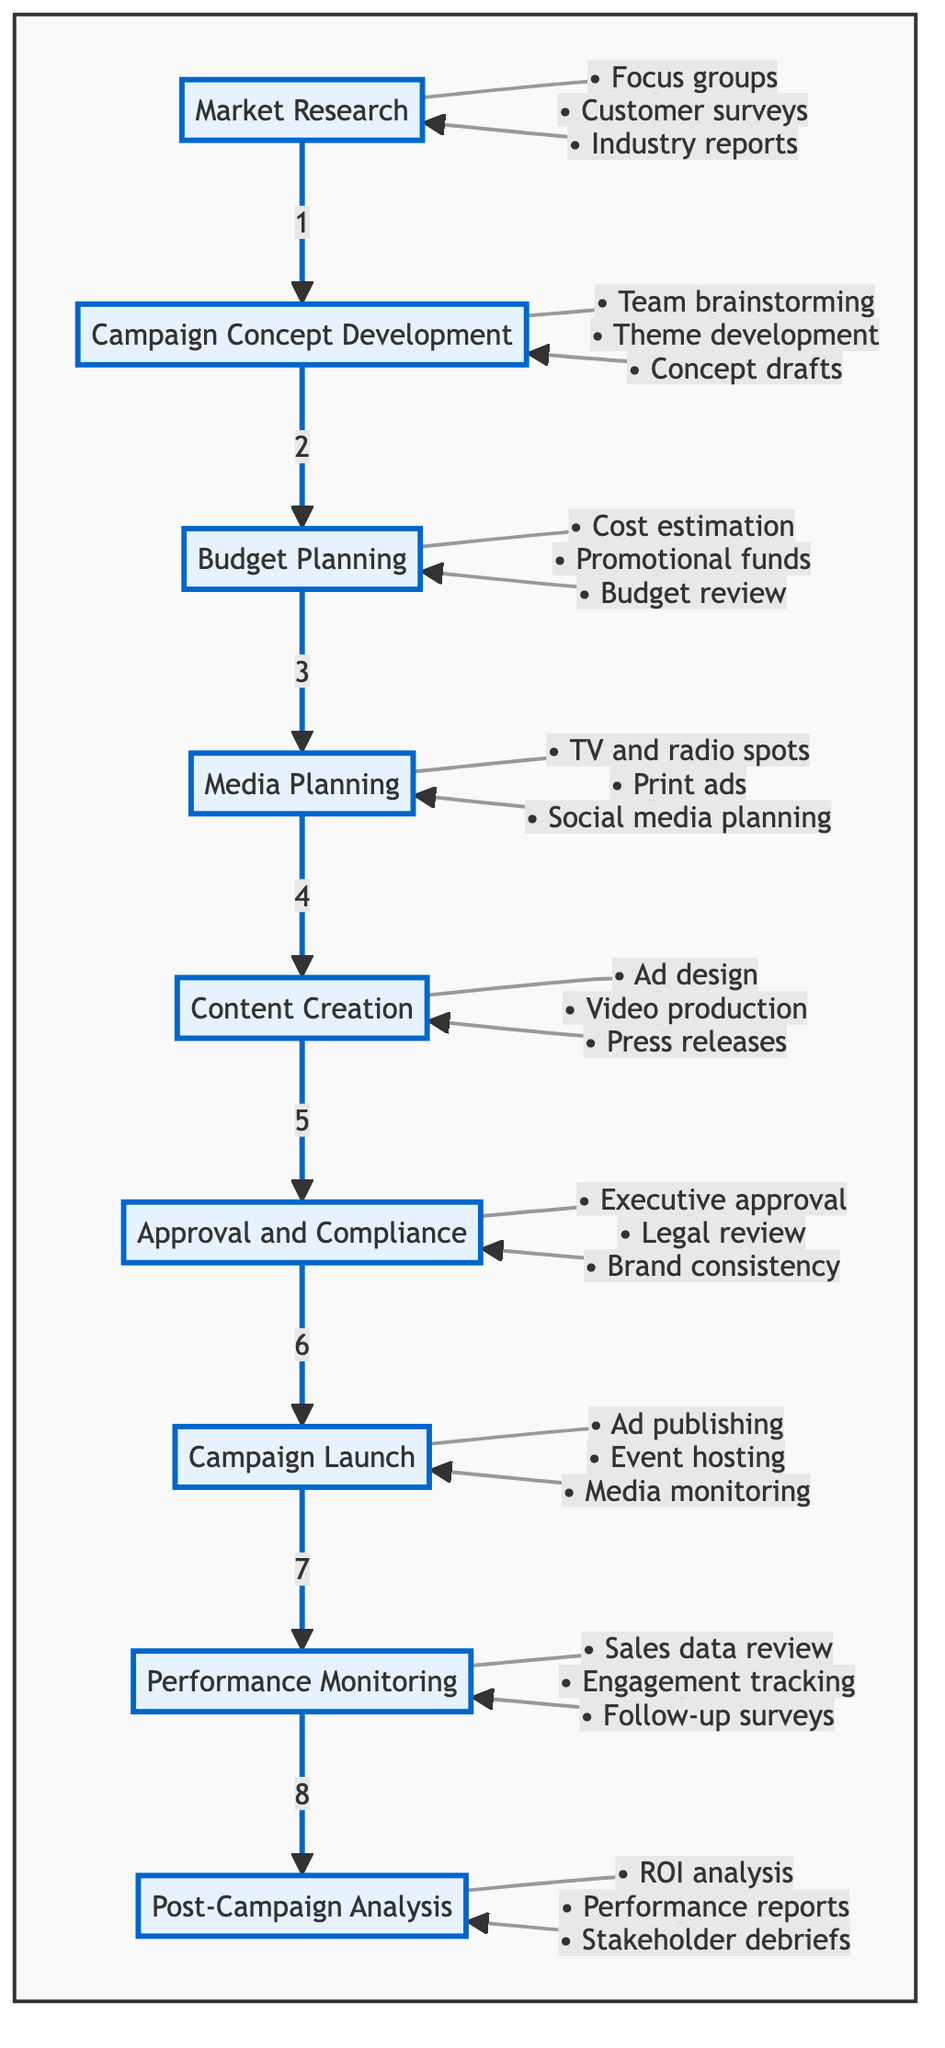What is the first stage of the campaign planning process? The diagram shows that the first stage is "Market Research", which is the initial step in the flowchart.
Answer: Market Research How many stages are there in the traditional marketing campaign planning process? By counting the nodes in the flowchart, there are a total of nine stages from Market Research to Post-Campaign Analysis.
Answer: 9 What is the last stage of the campaign planning process? According to the flowchart, the last stage is "Post-Campaign Analysis", which follows Performance Monitoring.
Answer: Post-Campaign Analysis Which task is included in the "Budget Planning" stage? The diagram lists "Estimate costs for advertising" as one of the tasks associated with Budget Planning, indicating an essential step in financial allocation.
Answer: Estimate costs for advertising What stage comes after "Content Creation"? The flowchart indicates that after the "Content Creation" stage, the next stage is "Approval and Compliance".
Answer: Approval and Compliance What does the "Media Planning" stage involve? The diagram specifies that Media Planning includes tasks like choosing media channels, including TV and radio spots, which are crucial for campaign dissemination.
Answer: Choose TV and radio spots How is the task of compliance ensured in the campaign planning process? "Approval and Compliance" stage ensures compliance through tasks like obtaining executive approval and reviewing content with the legal team to meet standards.
Answer: Obtain executive approval In which stage is the campaign launched? The flowchart clearly shows that the campaign is launched during the "Campaign Launch" stage, indicating the initiation point of the campaign across media channels.
Answer: Campaign Launch What is the purpose of "Post-Campaign Analysis"? The purpose, according to the diagram, is to evaluate the overall success of the campaign and identify lessons learned, providing insights for future campaigns.
Answer: Evaluate overall success 